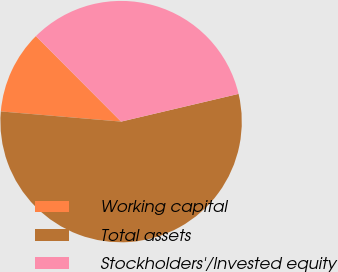<chart> <loc_0><loc_0><loc_500><loc_500><pie_chart><fcel>Working capital<fcel>Total assets<fcel>Stockholders'/Invested equity<nl><fcel>11.18%<fcel>55.03%<fcel>33.79%<nl></chart> 